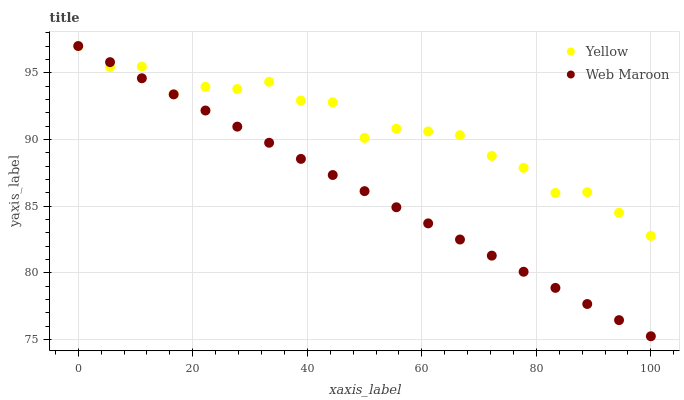Does Web Maroon have the minimum area under the curve?
Answer yes or no. Yes. Does Yellow have the maximum area under the curve?
Answer yes or no. Yes. Does Yellow have the minimum area under the curve?
Answer yes or no. No. Is Web Maroon the smoothest?
Answer yes or no. Yes. Is Yellow the roughest?
Answer yes or no. Yes. Is Yellow the smoothest?
Answer yes or no. No. Does Web Maroon have the lowest value?
Answer yes or no. Yes. Does Yellow have the lowest value?
Answer yes or no. No. Does Yellow have the highest value?
Answer yes or no. Yes. Does Web Maroon intersect Yellow?
Answer yes or no. Yes. Is Web Maroon less than Yellow?
Answer yes or no. No. Is Web Maroon greater than Yellow?
Answer yes or no. No. 